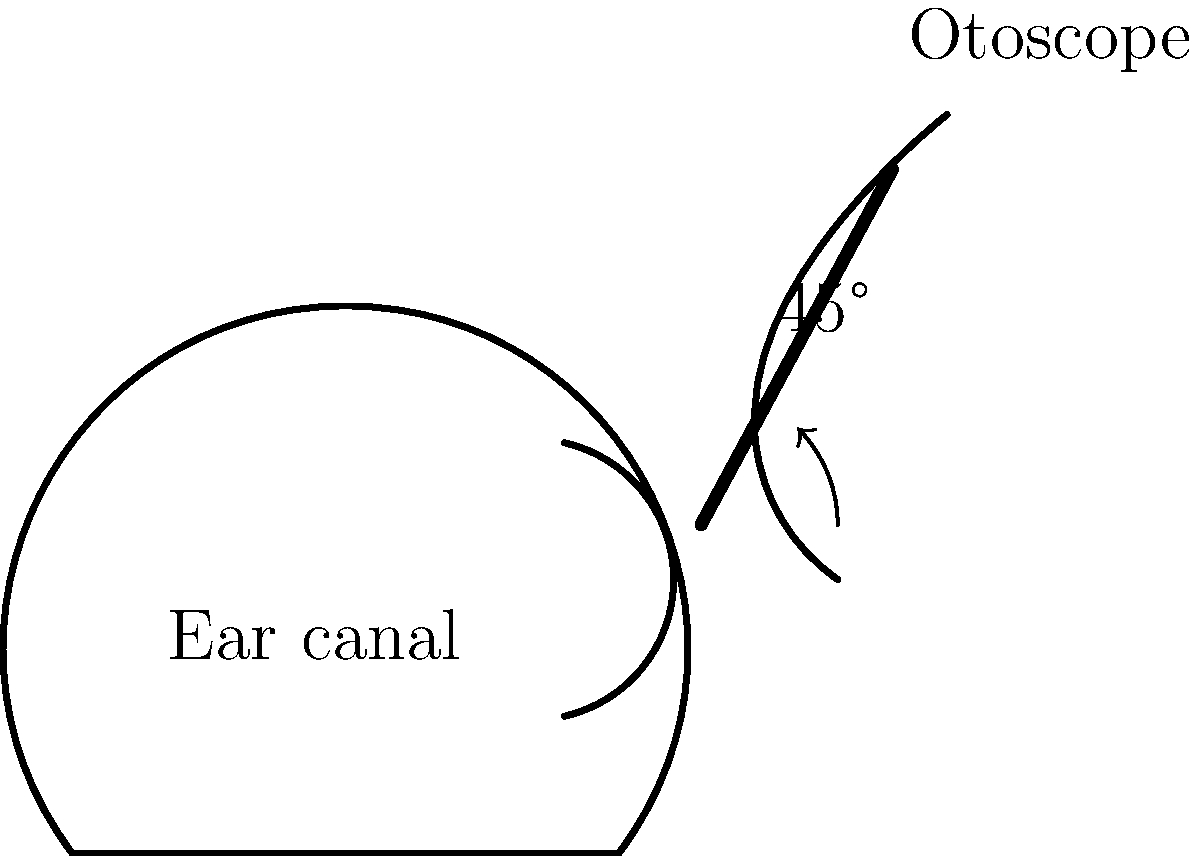In the otoscopic examination of a child's ear, what is the correct angle at which the otoscope should be held relative to the child's head, and why is this angle important? The correct technique for otoscopic examination in children involves several key steps:

1. Positioning: The child should be seated comfortably, with their head tilted slightly towards the opposite shoulder.

2. Otoscope angle: The otoscope should be held at a 45-degree angle relative to the child's head. This is crucial because:
   a) It aligns with the natural angle of the child's ear canal, which is more horizontal than in adults.
   b) It helps straighten the ear canal, providing a better view of the tympanic membrane.

3. Ear traction: Gently pull the pinna (outer ear) backwards and slightly upwards for children over 3 years old, or straight back for infants and toddlers. This helps straighten the ear canal further.

4. Insertion: Carefully insert the speculum of the otoscope into the ear canal, following its natural curve.

5. Visualization: Look through the otoscope to examine the ear canal and tympanic membrane, noting any abnormalities.

The 45-degree angle is particularly important because:
- It minimizes discomfort for the child
- It provides the best view of the tympanic membrane
- It reduces the risk of injury to the ear canal

Maintaining this angle throughout the examination ensures accurate diagnosis and assessment of conditions such as otitis media, which is common in children.
Answer: 45 degrees; aligns with child's ear canal anatomy for optimal visualization and safety 